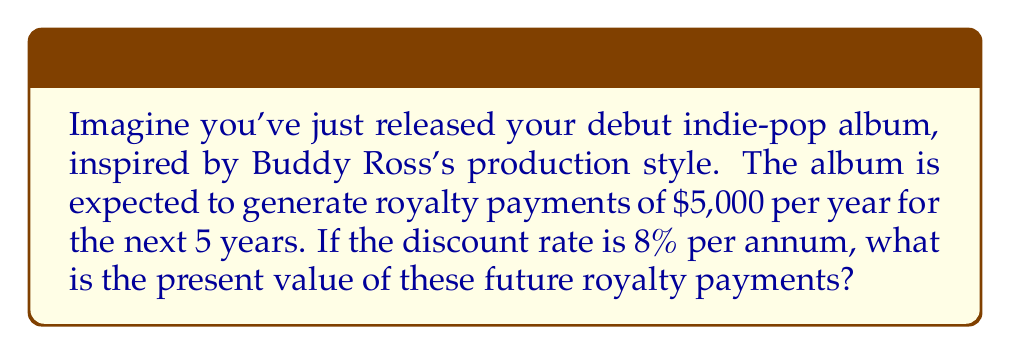Help me with this question. To calculate the present value of future royalty payments, we need to use the present value of an annuity formula. In this case, we have a series of equal payments (royalties) over a fixed period, which constitutes an ordinary annuity.

The formula for the present value of an ordinary annuity is:

$$PV = PMT \times \frac{1 - (1 + r)^{-n}}{r}$$

Where:
$PV$ = Present Value
$PMT$ = Payment amount (annual royalty)
$r$ = Discount rate (as a decimal)
$n$ = Number of periods (years)

Given:
$PMT = \$5,000$ (annual royalty)
$r = 0.08$ (8% discount rate)
$n = 5$ years

Let's substitute these values into the formula:

$$PV = 5000 \times \frac{1 - (1 + 0.08)^{-5}}{0.08}$$

Now, let's solve step by step:

1. Calculate $(1 + 0.08)^{-5}$:
   $$(1.08)^{-5} = 0.6805556$$

2. Subtract this value from 1:
   $$1 - 0.6805556 = 0.3194444$$

3. Divide by the discount rate:
   $$\frac{0.3194444}{0.08} = 3.9930556$$

4. Multiply by the annual payment:
   $$5000 \times 3.9930556 = 19,965.28$$

Therefore, the present value of the future royalty payments is $19,965.28.
Answer: $19,965.28 